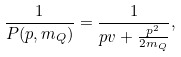Convert formula to latex. <formula><loc_0><loc_0><loc_500><loc_500>\frac { 1 } { P ( p , m _ { Q } ) } = \frac { 1 } { p v + \frac { p ^ { 2 } } { 2 m _ { Q } } } ,</formula> 